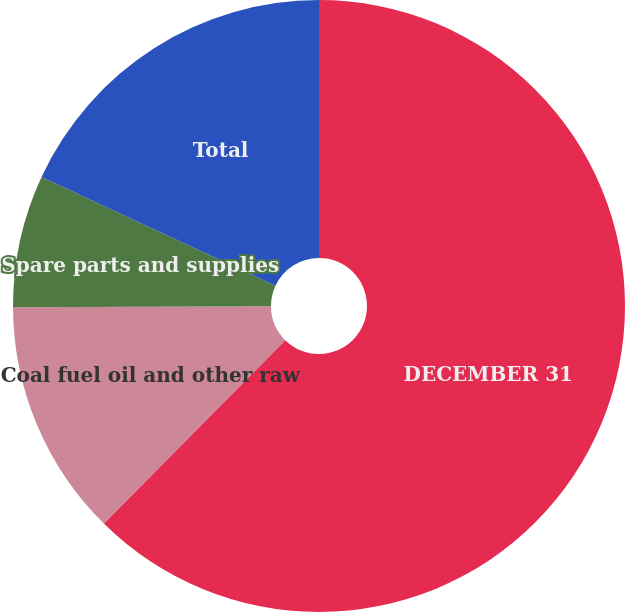Convert chart. <chart><loc_0><loc_0><loc_500><loc_500><pie_chart><fcel>DECEMBER 31<fcel>Coal fuel oil and other raw<fcel>Spare parts and supplies<fcel>Total<nl><fcel>62.41%<fcel>12.53%<fcel>6.99%<fcel>18.07%<nl></chart> 